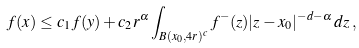Convert formula to latex. <formula><loc_0><loc_0><loc_500><loc_500>f ( x ) \leq c _ { 1 } f ( y ) + c _ { 2 } r ^ { \alpha } \int _ { B ( x _ { 0 } , 4 r ) ^ { c } } f ^ { - } ( z ) | z - x _ { 0 } | ^ { - d - \alpha } \, d z \, ,</formula> 